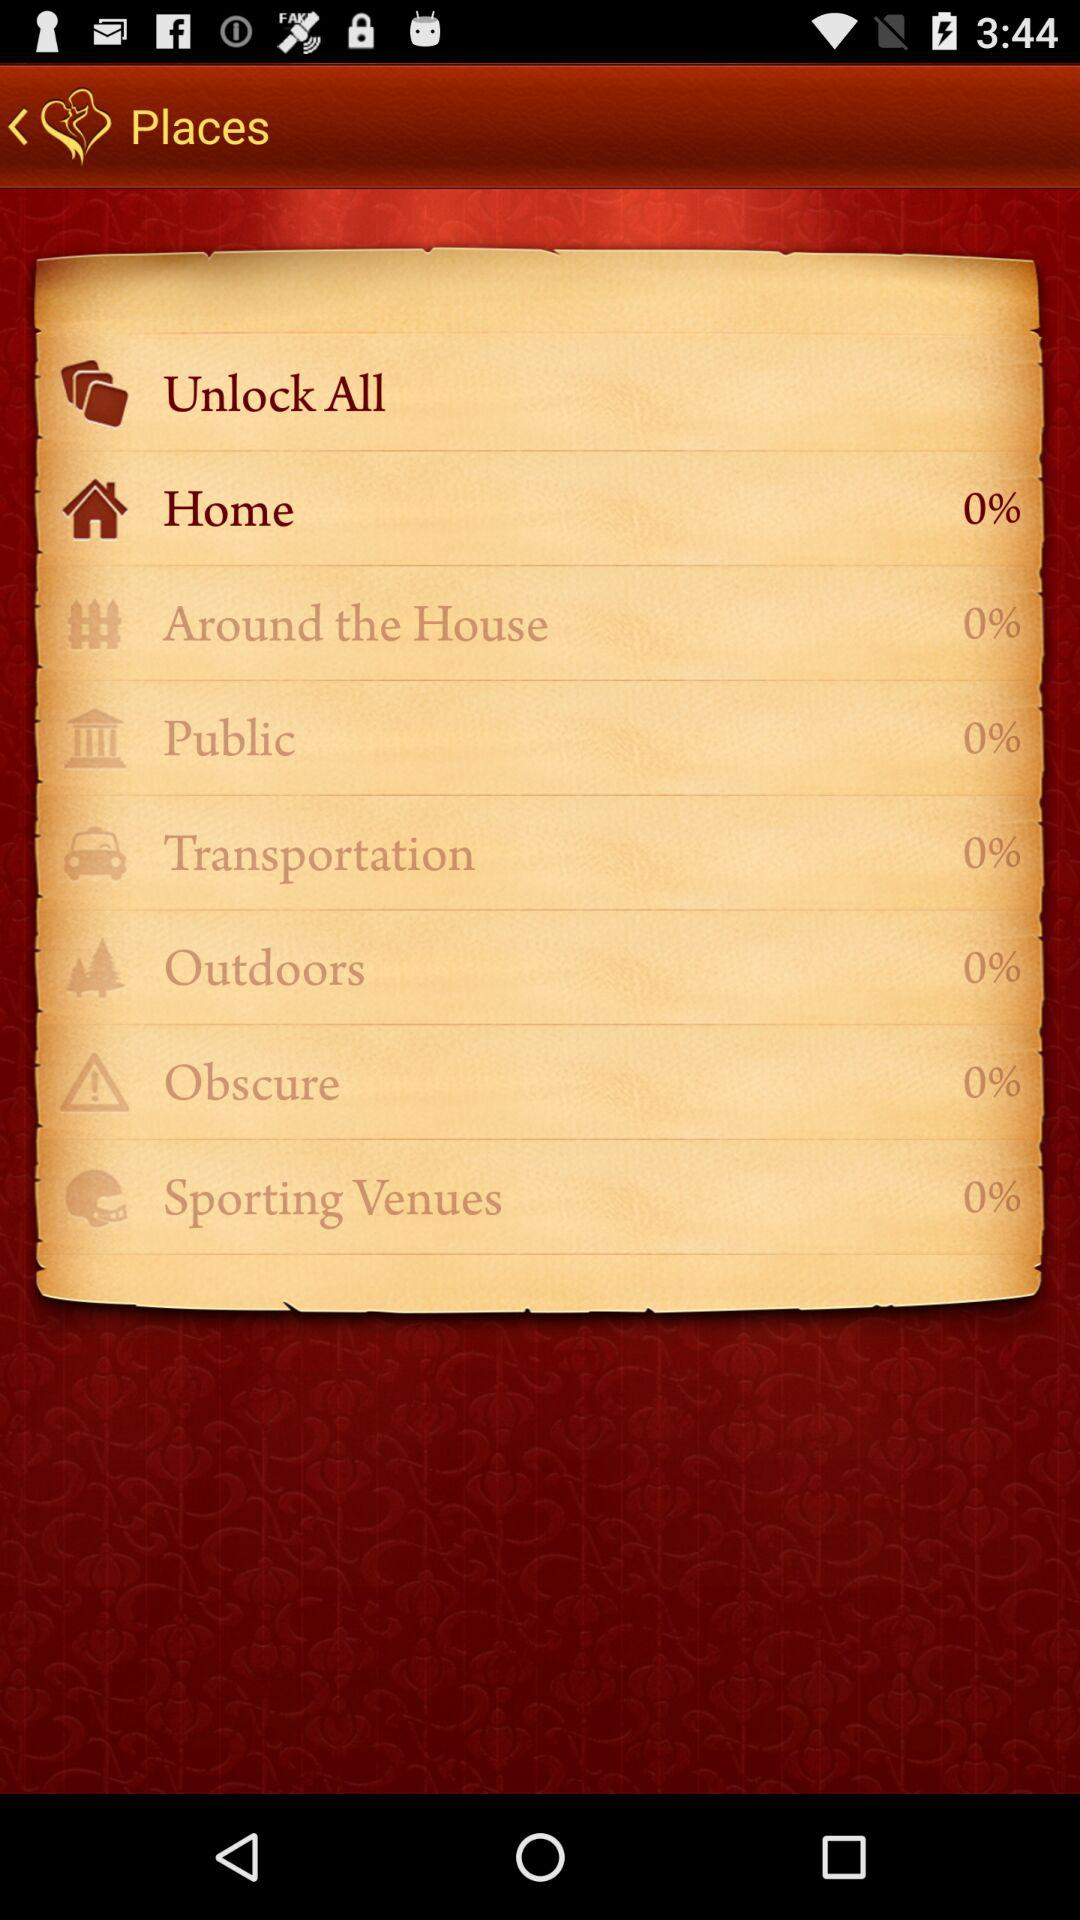What is the percentage shown for "Home"? The percentage shown for "Home" is 0. 